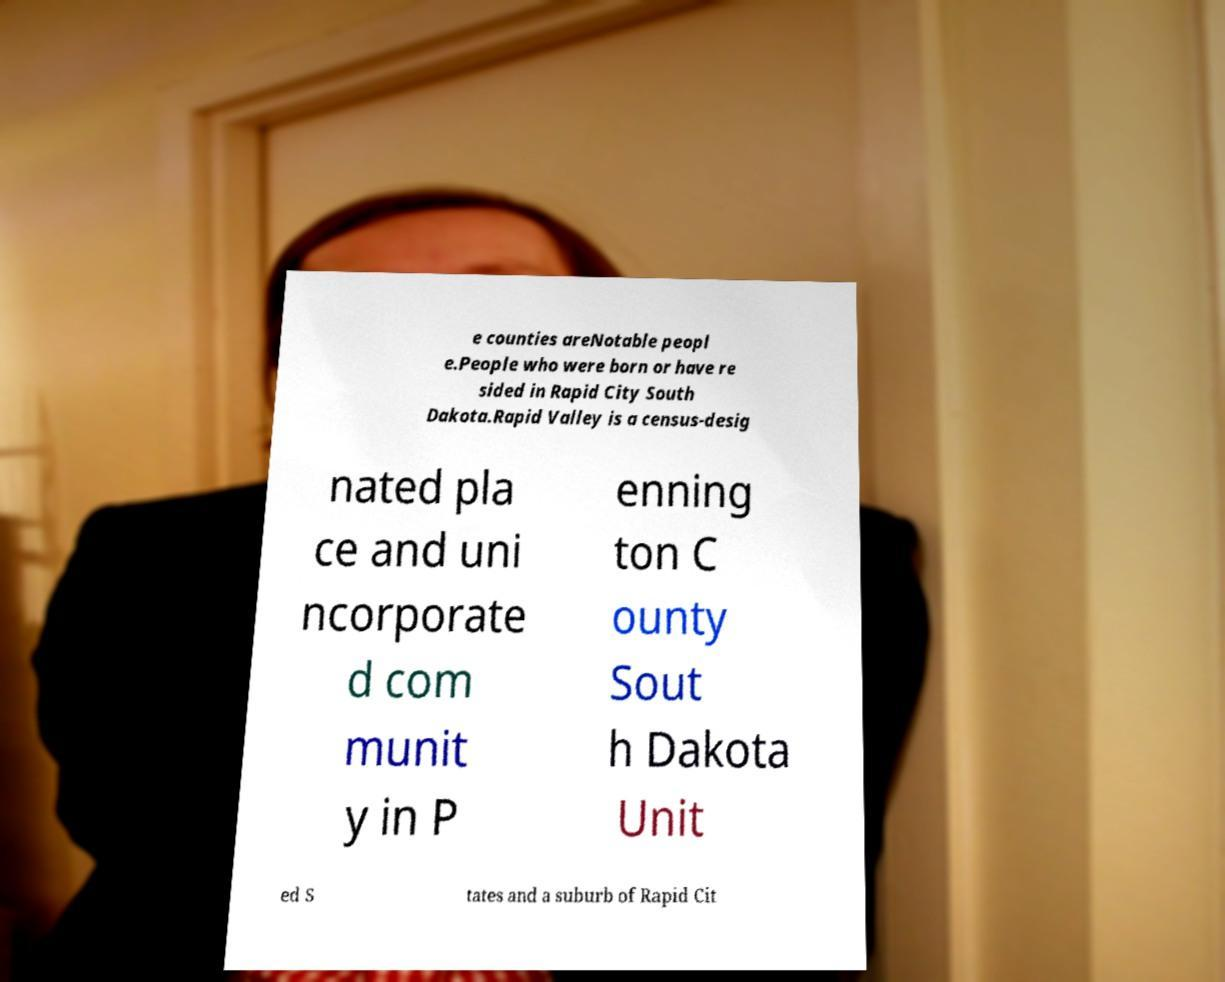Could you assist in decoding the text presented in this image and type it out clearly? e counties areNotable peopl e.People who were born or have re sided in Rapid City South Dakota.Rapid Valley is a census-desig nated pla ce and uni ncorporate d com munit y in P enning ton C ounty Sout h Dakota Unit ed S tates and a suburb of Rapid Cit 